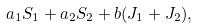Convert formula to latex. <formula><loc_0><loc_0><loc_500><loc_500>a _ { 1 } S _ { 1 } + a _ { 2 } S _ { 2 } + b ( J _ { 1 } + J _ { 2 } ) ,</formula> 